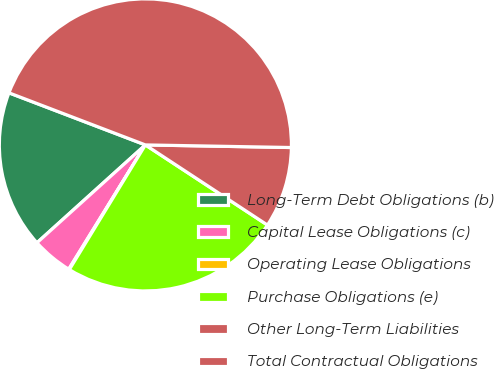Convert chart. <chart><loc_0><loc_0><loc_500><loc_500><pie_chart><fcel>Long-Term Debt Obligations (b)<fcel>Capital Lease Obligations (c)<fcel>Operating Lease Obligations<fcel>Purchase Obligations (e)<fcel>Other Long-Term Liabilities<fcel>Total Contractual Obligations<nl><fcel>17.49%<fcel>4.52%<fcel>0.08%<fcel>24.47%<fcel>8.96%<fcel>44.48%<nl></chart> 